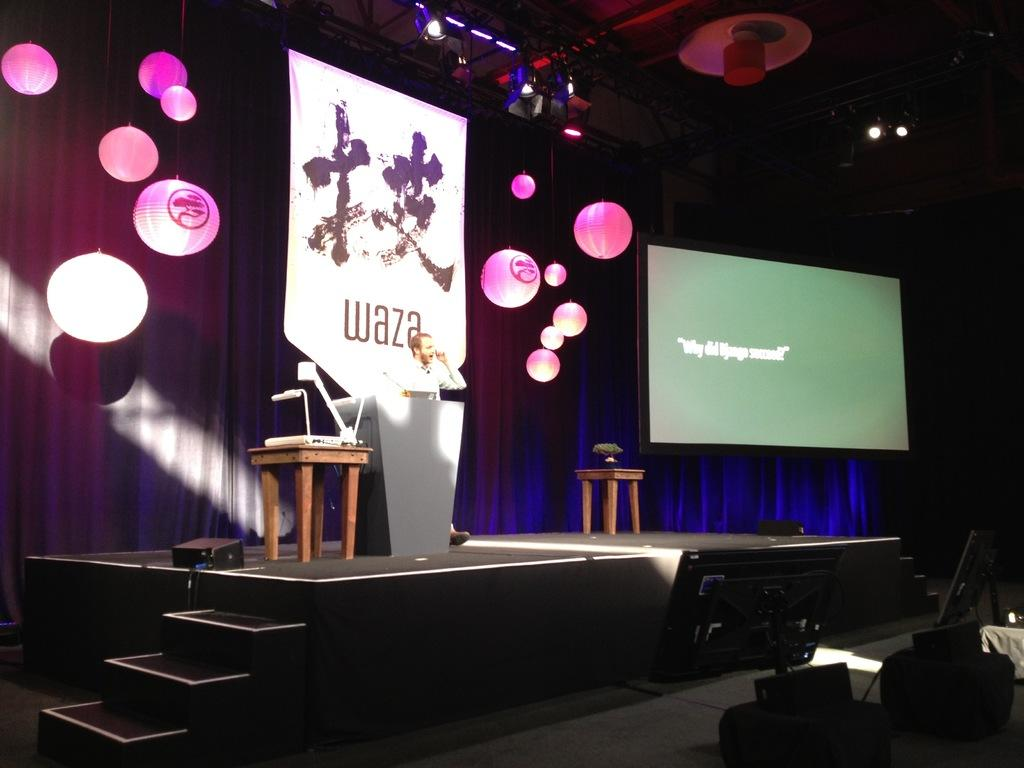What is the main subject of the image? There is a person standing on the stage. What is the person doing on the stage? The person is speaking. What can be seen behind the person on the stage? There is a banner behind the person. What is written on the banner? Text is written on the banner. What type of haircut does the person on the stage have? There is no information about the person's haircut in the image, so it cannot be determined. What decision is the person on the stage making? There is no indication of a decision being made in the image; the person is simply speaking. 